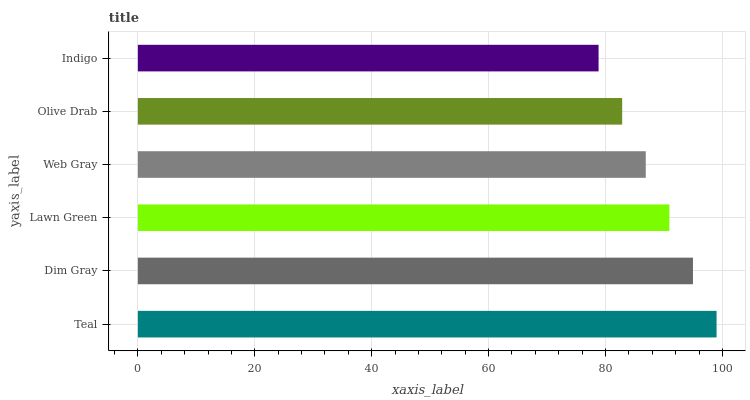Is Indigo the minimum?
Answer yes or no. Yes. Is Teal the maximum?
Answer yes or no. Yes. Is Dim Gray the minimum?
Answer yes or no. No. Is Dim Gray the maximum?
Answer yes or no. No. Is Teal greater than Dim Gray?
Answer yes or no. Yes. Is Dim Gray less than Teal?
Answer yes or no. Yes. Is Dim Gray greater than Teal?
Answer yes or no. No. Is Teal less than Dim Gray?
Answer yes or no. No. Is Lawn Green the high median?
Answer yes or no. Yes. Is Web Gray the low median?
Answer yes or no. Yes. Is Olive Drab the high median?
Answer yes or no. No. Is Dim Gray the low median?
Answer yes or no. No. 